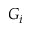<formula> <loc_0><loc_0><loc_500><loc_500>G _ { i }</formula> 